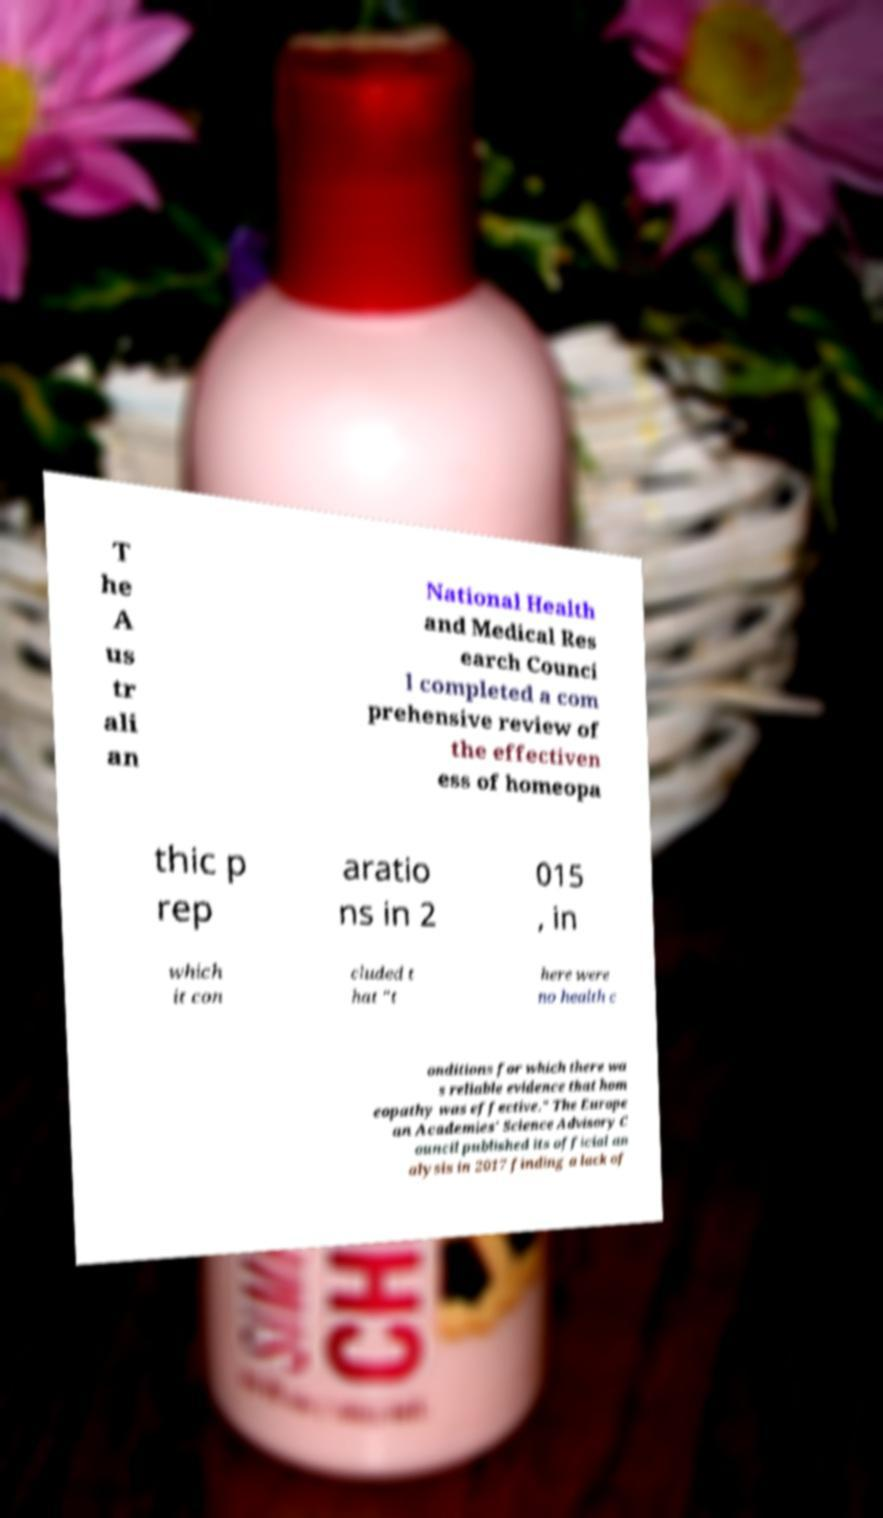Please identify and transcribe the text found in this image. T he A us tr ali an National Health and Medical Res earch Counci l completed a com prehensive review of the effectiven ess of homeopa thic p rep aratio ns in 2 015 , in which it con cluded t hat "t here were no health c onditions for which there wa s reliable evidence that hom eopathy was effective." The Europe an Academies' Science Advisory C ouncil published its official an alysis in 2017 finding a lack of 